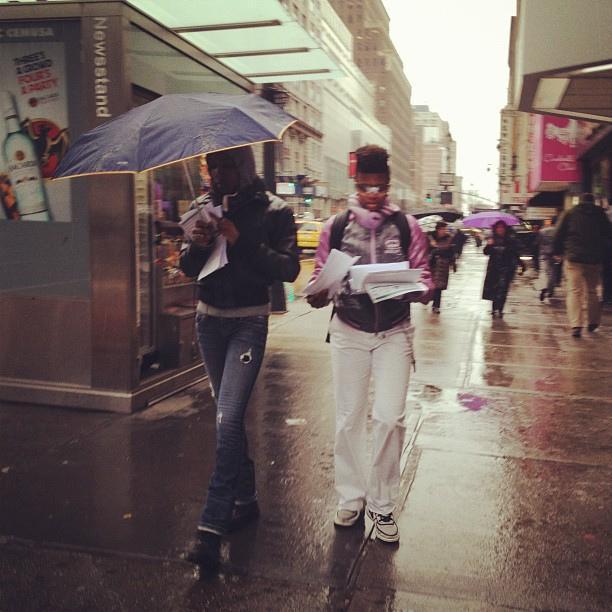How many strollers are there?
Give a very brief answer. 0. How many people are in the photo?
Give a very brief answer. 4. 